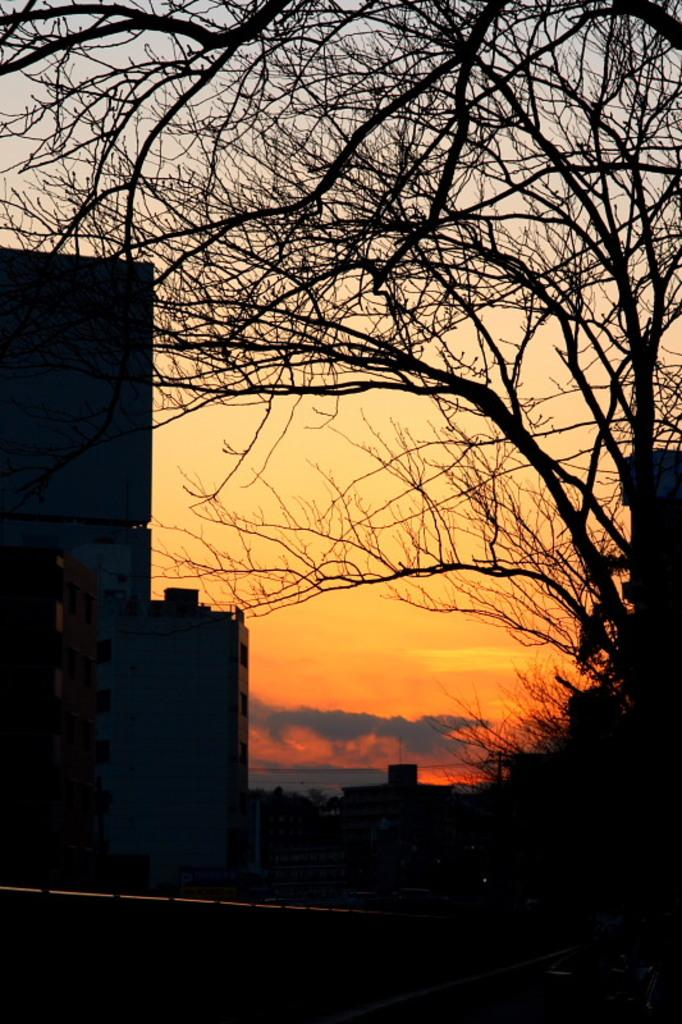What type of structures can be seen in the image? There are buildings in the image. What other natural elements are present in the image? There are trees in the image. How would you describe the weather based on the image? The sky is cloudy in the image, suggesting a potentially overcast or cloudy day. What is the chance of finding a hospital in the image? There is no information about a hospital in the image, so it's not possible to determine the chance of finding one. 